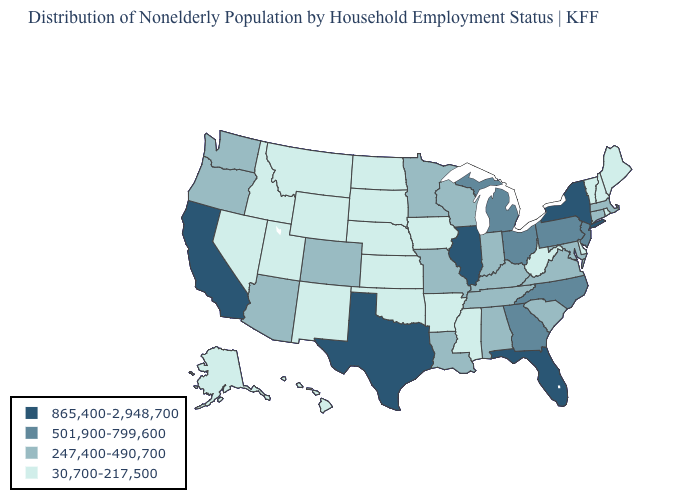Which states have the lowest value in the USA?
Keep it brief. Alaska, Arkansas, Delaware, Hawaii, Idaho, Iowa, Kansas, Maine, Mississippi, Montana, Nebraska, Nevada, New Hampshire, New Mexico, North Dakota, Oklahoma, Rhode Island, South Dakota, Utah, Vermont, West Virginia, Wyoming. What is the value of North Carolina?
Keep it brief. 501,900-799,600. Which states have the highest value in the USA?
Short answer required. California, Florida, Illinois, New York, Texas. What is the value of South Dakota?
Write a very short answer. 30,700-217,500. Which states have the lowest value in the South?
Write a very short answer. Arkansas, Delaware, Mississippi, Oklahoma, West Virginia. Among the states that border Idaho , which have the highest value?
Concise answer only. Oregon, Washington. What is the value of Arkansas?
Short answer required. 30,700-217,500. Which states have the lowest value in the MidWest?
Keep it brief. Iowa, Kansas, Nebraska, North Dakota, South Dakota. Does West Virginia have the same value as Connecticut?
Quick response, please. No. Name the states that have a value in the range 247,400-490,700?
Answer briefly. Alabama, Arizona, Colorado, Connecticut, Indiana, Kentucky, Louisiana, Maryland, Massachusetts, Minnesota, Missouri, Oregon, South Carolina, Tennessee, Virginia, Washington, Wisconsin. What is the highest value in the Northeast ?
Write a very short answer. 865,400-2,948,700. Does Ohio have the lowest value in the MidWest?
Quick response, please. No. Which states hav the highest value in the MidWest?
Give a very brief answer. Illinois. Name the states that have a value in the range 247,400-490,700?
Quick response, please. Alabama, Arizona, Colorado, Connecticut, Indiana, Kentucky, Louisiana, Maryland, Massachusetts, Minnesota, Missouri, Oregon, South Carolina, Tennessee, Virginia, Washington, Wisconsin. What is the value of Wyoming?
Concise answer only. 30,700-217,500. 